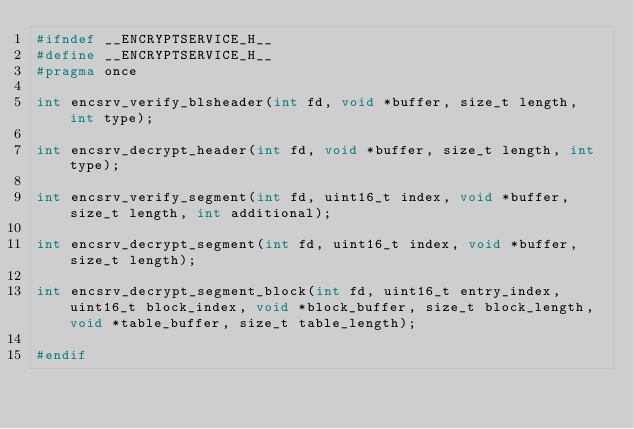Convert code to text. <code><loc_0><loc_0><loc_500><loc_500><_C_>#ifndef __ENCRYPTSERVICE_H__
#define __ENCRYPTSERVICE_H__
#pragma once

int encsrv_verify_blsheader(int fd, void *buffer, size_t length, int type);

int encsrv_decrypt_header(int fd, void *buffer, size_t length, int type);

int encsrv_verify_segment(int fd, uint16_t index, void *buffer, size_t length, int additional);

int encsrv_decrypt_segment(int fd, uint16_t index, void *buffer, size_t length);

int encsrv_decrypt_segment_block(int fd, uint16_t entry_index, uint16_t block_index, void *block_buffer, size_t block_length, void *table_buffer, size_t table_length);

#endif
</code> 